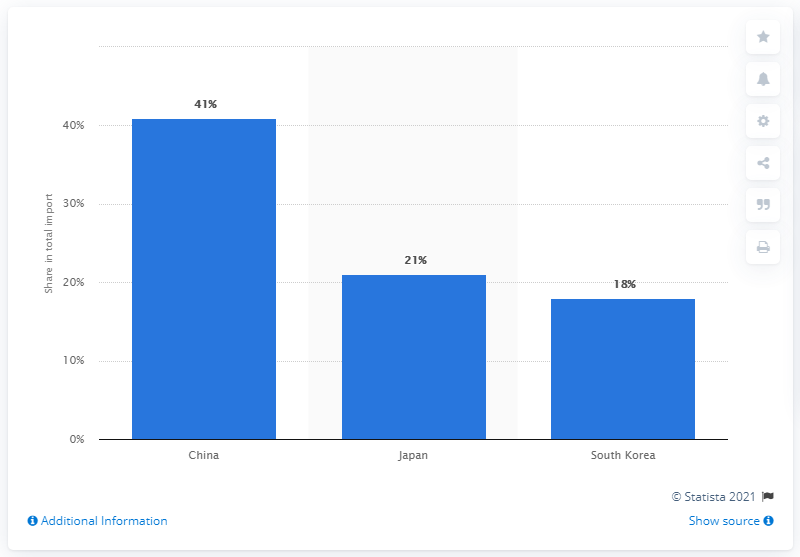Give some essential details in this illustration. In 2019, China was the most significant import partner for Liberia, accounting for a significant portion of the country's imports. 